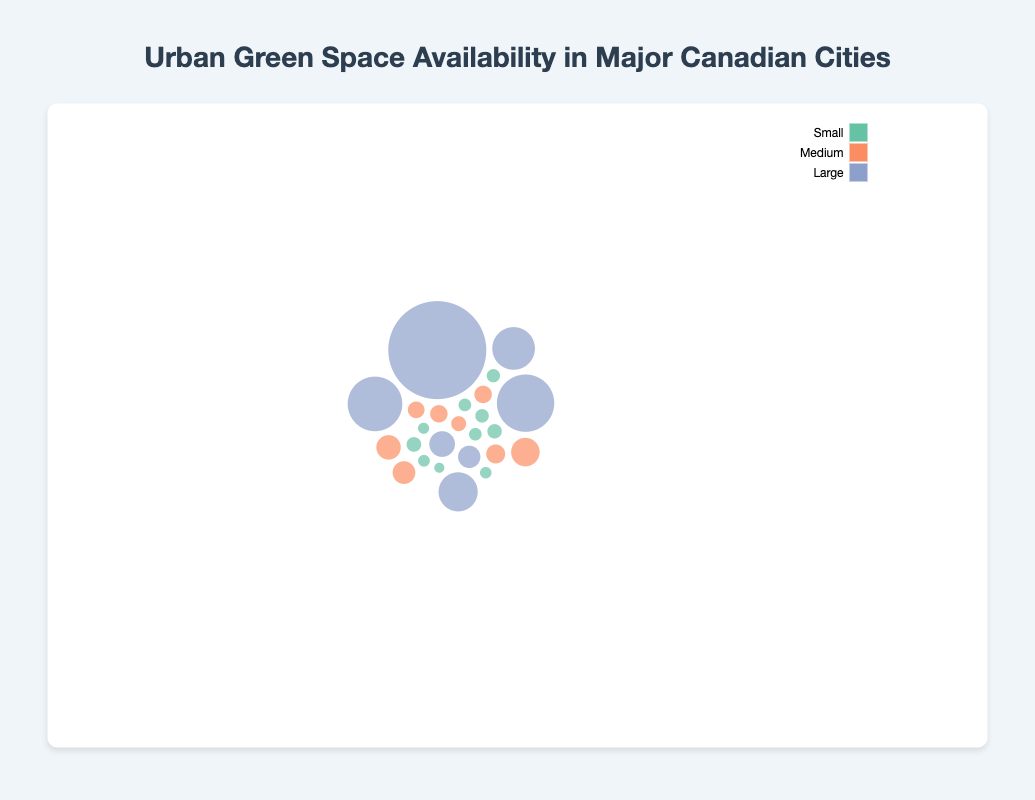What is the largest park in Vancouver? In the bubble chart, identify the bubble representing the largest area for Vancouver parks, which corresponds to Stanley Park. According to the legend and size of the bubble, Stanley Park is the largest park in Vancouver with 405 hectares.
Answer: Stanley Park Which city has the largest number of small parks? Count the number of bubbles colored according to the category of Small in each city. Toronto has 2 small parks, Vancouver has 3, Montreal has 1, Calgary has 2, and Ottawa has 2. Therefore, Vancouver has the largest number of small parks.
Answer: Vancouver What is the combined size of medium-sized parks in Toronto? Sum the sizes of the parks in Toronto that fall under the Medium category. Trinity Bellwoods Park (14.6 ha) and Queen's Park (7.9 ha), give us a total. 14.6 + 7.9 = 22.5 hectares.
Answer: 22.5 hectares Which city has the second largest large park? Identify the largest parks in each city from the Large category and rank them. The areas are as follows: Toronto (161 ha: High Park), Vancouver (405 ha: Stanley Park), Montreal (200 ha: Parc du Mont-Royal), Calgary (1348 ha: Fish Creek Provincial Park), Ottawa (361 ha: Gatineau Park). Thus, Montreal's Parc du Mont-Royal is the second largest.
Answer: Montreal What are the categories of parks found in Montreal according to the figure? Identify all the unique categories of parks in Montreal by checking the bubbles' colors. We see parks categorized as Small (Square Saint-Louis), Medium (Parc Jarry, Parc Jeanne-Mance), and Large (Parc du Mont-Royal, Parc-La Fontaine) in Montreal.
Answer: Small, Medium, Large Which city has the park with the smallest size? Identify the smallest bubble in the figure irrespective of the city. The smallest size in the dataset is 0.7 ha for Square Saint-Louis in Montreal.
Answer: Montreal What is the total green space (in hectares) available in Ottawa? Sum the sizes of all the parks in Ottawa: Gatineau Park (361 ha), Mooney's Bay Park (70 ha), Andrew Haydon Park (45 ha), Major's Hill Park (5 ha), and Confederation Park (2 ha). The sum is 361 + 70 + 45 + 5 + 2 = 483 hectares.
Answer: 483 hectares Which category of parks have the most diverse sizes in Toronto? Compare the range (max-min) of sizes for each category of parks in Toronto. Large ranges from 161 ha (only one park), Medium ranges from 7.9 to 14.6 ha (difference of 6.7 ha), Small ranges from 3.6 to 7.3 ha (difference of 3.7 ha). Thus, Medium has the most diverse sizes.
Answer: Medium Which city appears to have a more balanced distribution across park size categories? Identify the cities with parks distributed evenly across Small, Medium, and Large categories. Cities like Calgary and Ottawa have parks in each size category (Large, Medium, Small), while others may predominantly have one or two categories. Both Calgary and Ottawa have a balanced distribution, but Ottawa best fits because each category is more equally represented in number.
Answer: Ottawa 